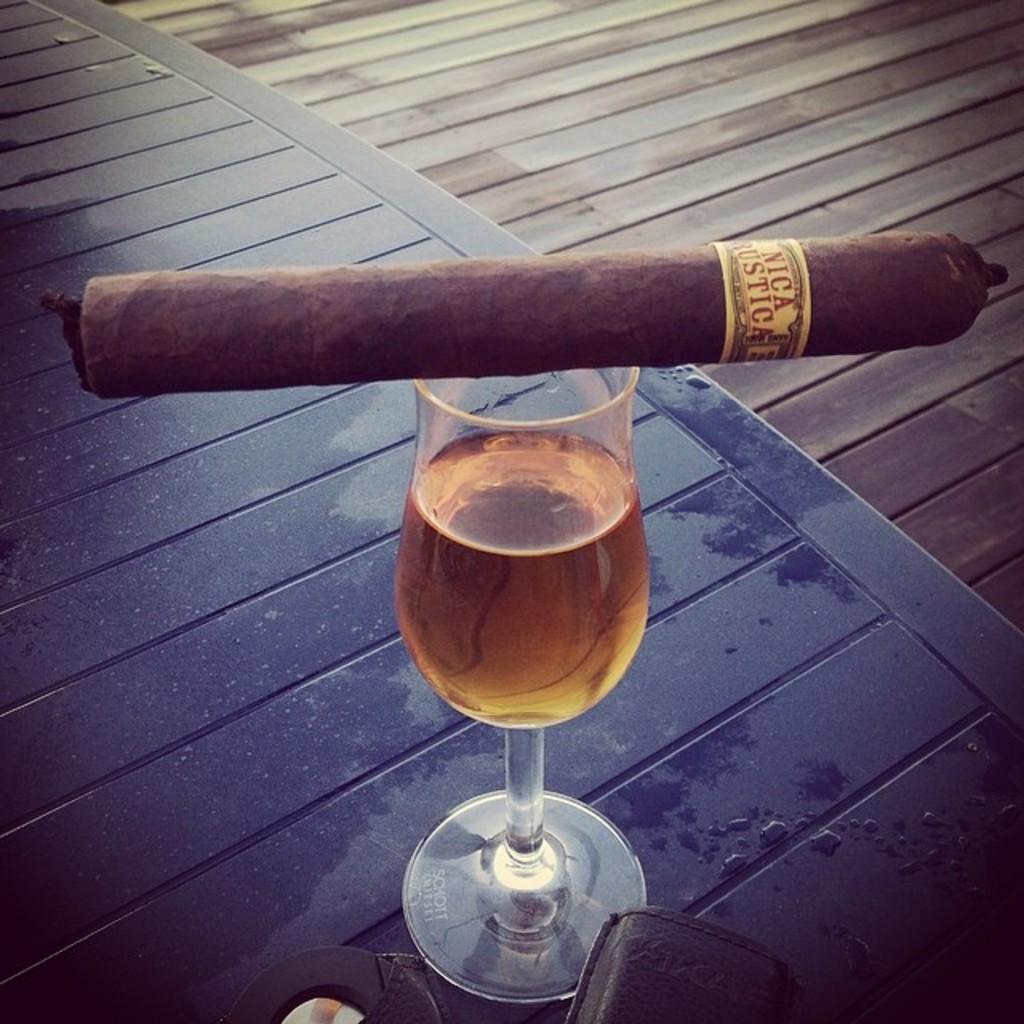In one or two sentences, can you explain what this image depicts? In this image there is a wine glass on the wooden table. There is drink in the glass. There is a cigar on the glass. Beside the table there is a wooden floor. At the bottom there are objects on the table. 